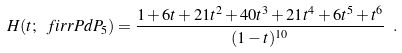<formula> <loc_0><loc_0><loc_500><loc_500>H ( t ; \ f i r r { P d P _ { 5 } } ) = \frac { 1 + 6 t + 2 1 t ^ { 2 } + 4 0 t ^ { 3 } + 2 1 t ^ { 4 } + 6 t ^ { 5 } + t ^ { 6 } } { ( 1 - t ) ^ { 1 0 } } \ .</formula> 